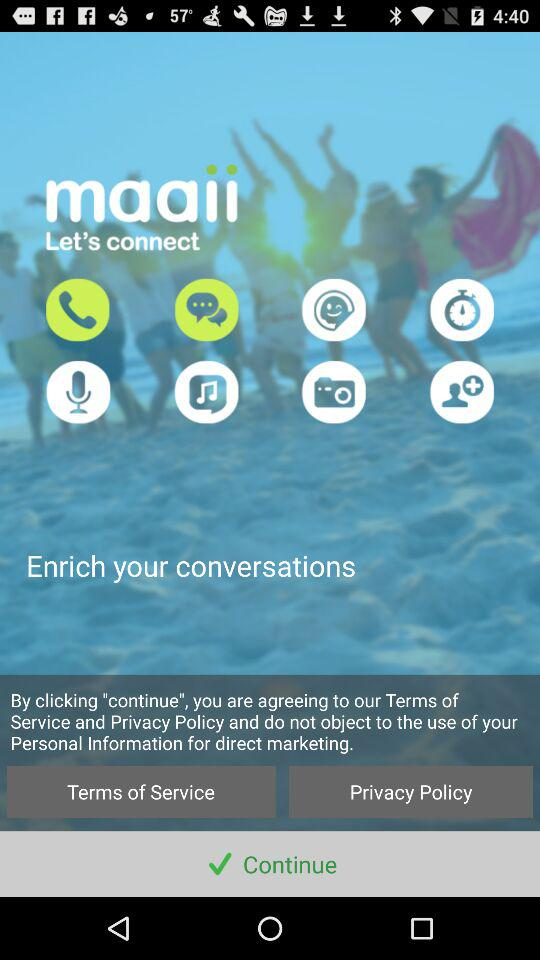What is the name of the application? The name of the application is "maaii". 